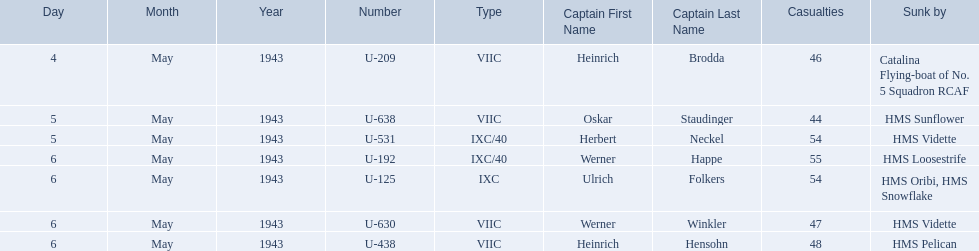Which were the names of the sinkers of the convoys? Catalina Flying-boat of No. 5 Squadron RCAF, HMS Sunflower, HMS Vidette, HMS Loosestrife, HMS Oribi, HMS Snowflake, HMS Vidette, HMS Pelican. What captain was sunk by the hms pelican? Heinrich Hensohn. 